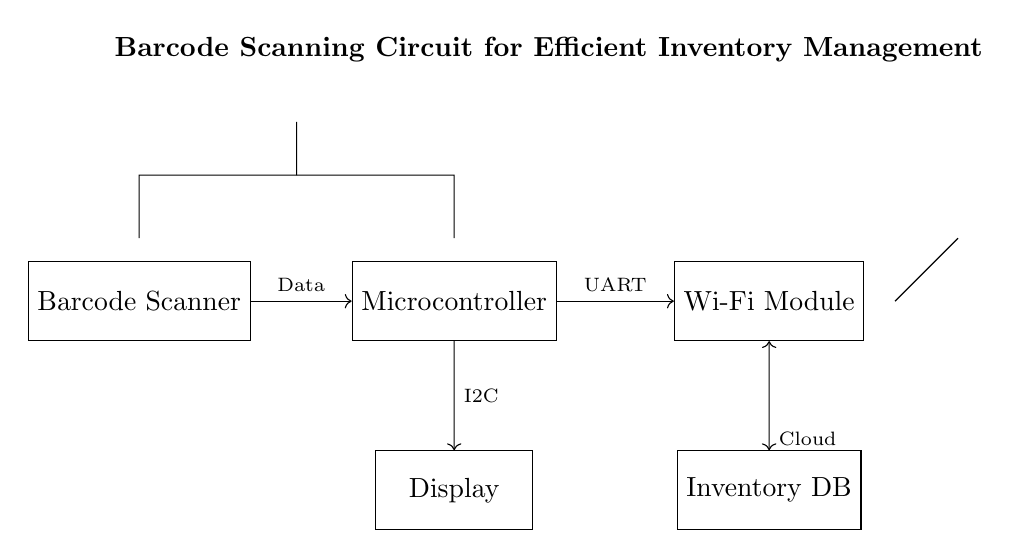What is the main component used for scanning barcodes? The main component for scanning barcodes is the Barcode Scanner, which is shown as a rectangle in the circuit diagram.
Answer: Barcode Scanner What type of communication is used between the microcontroller and the Wi-Fi module? The communication type is specified as UART, which is displayed as an arrow label between the microcontroller and the Wi-Fi module.
Answer: UART How many main components are displayed in the circuit? The main components are the Barcode Scanner, Microcontroller, Wi-Fi Module, Antenna, Display, and Inventory Database. Counting these gives a total of six components.
Answer: Six What is the purpose of the display in this circuit? The purpose of the display is to show the data processed by the microcontroller, with the connection labeled I2C indicating the communication type used for this purpose.
Answer: Show data Which connection type indicates data flow from the scanner to the microcontroller? The connection type is labeled Data, shown by an arrow from the Barcode Scanner to the Microcontroller, indicating the direction of the data flow.
Answer: Data How is the inventory database accessed in this circuit? The inventory database is accessed via a cloud connection as indicated by a bidirectional arrow between the Wi-Fi Module and the Inventory Database, highlighting that data can both be sent to and received from the database.
Answer: Cloud What does the power supply use in this circuit? The power supply uses a battery, indicated by the battery symbol at the top of the circuit diagram which represents the source of power for the entire system.
Answer: Battery 